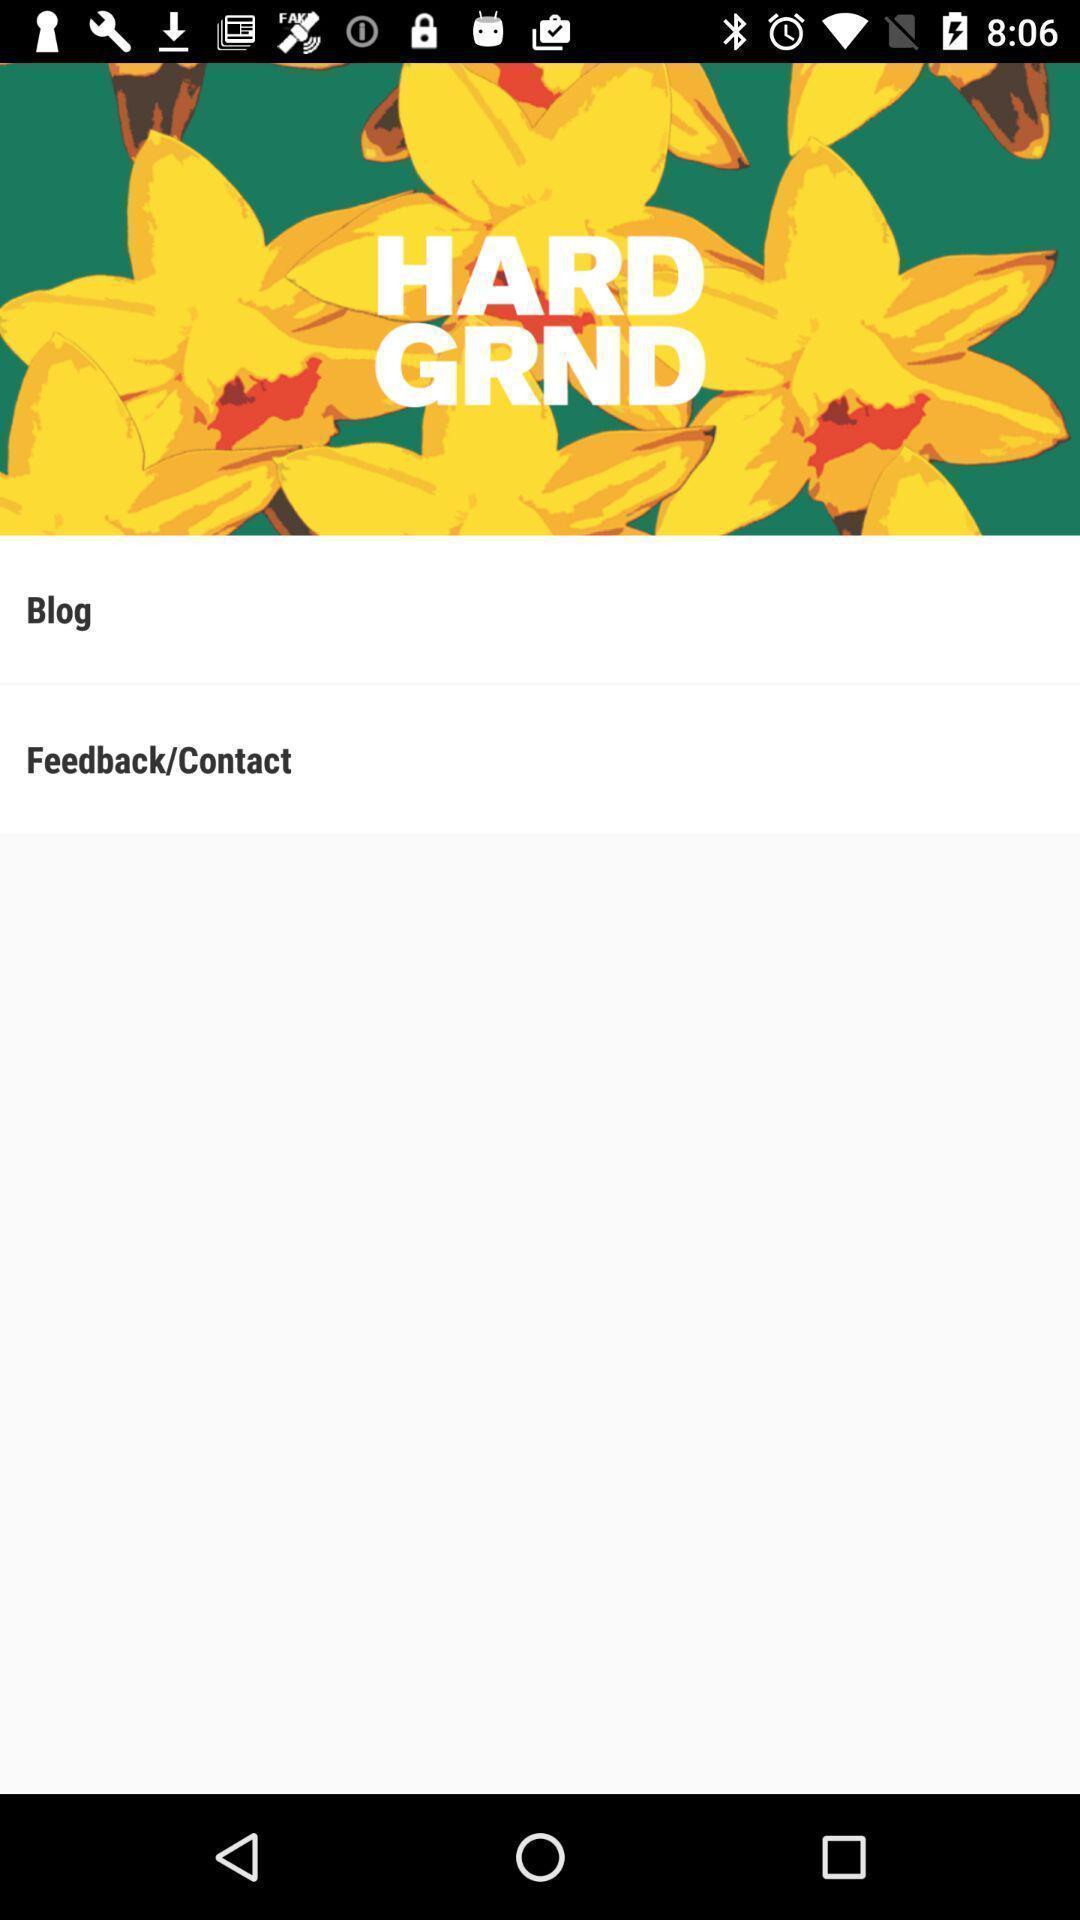Describe this image in words. Page to check advanced information on soccer cleats. 